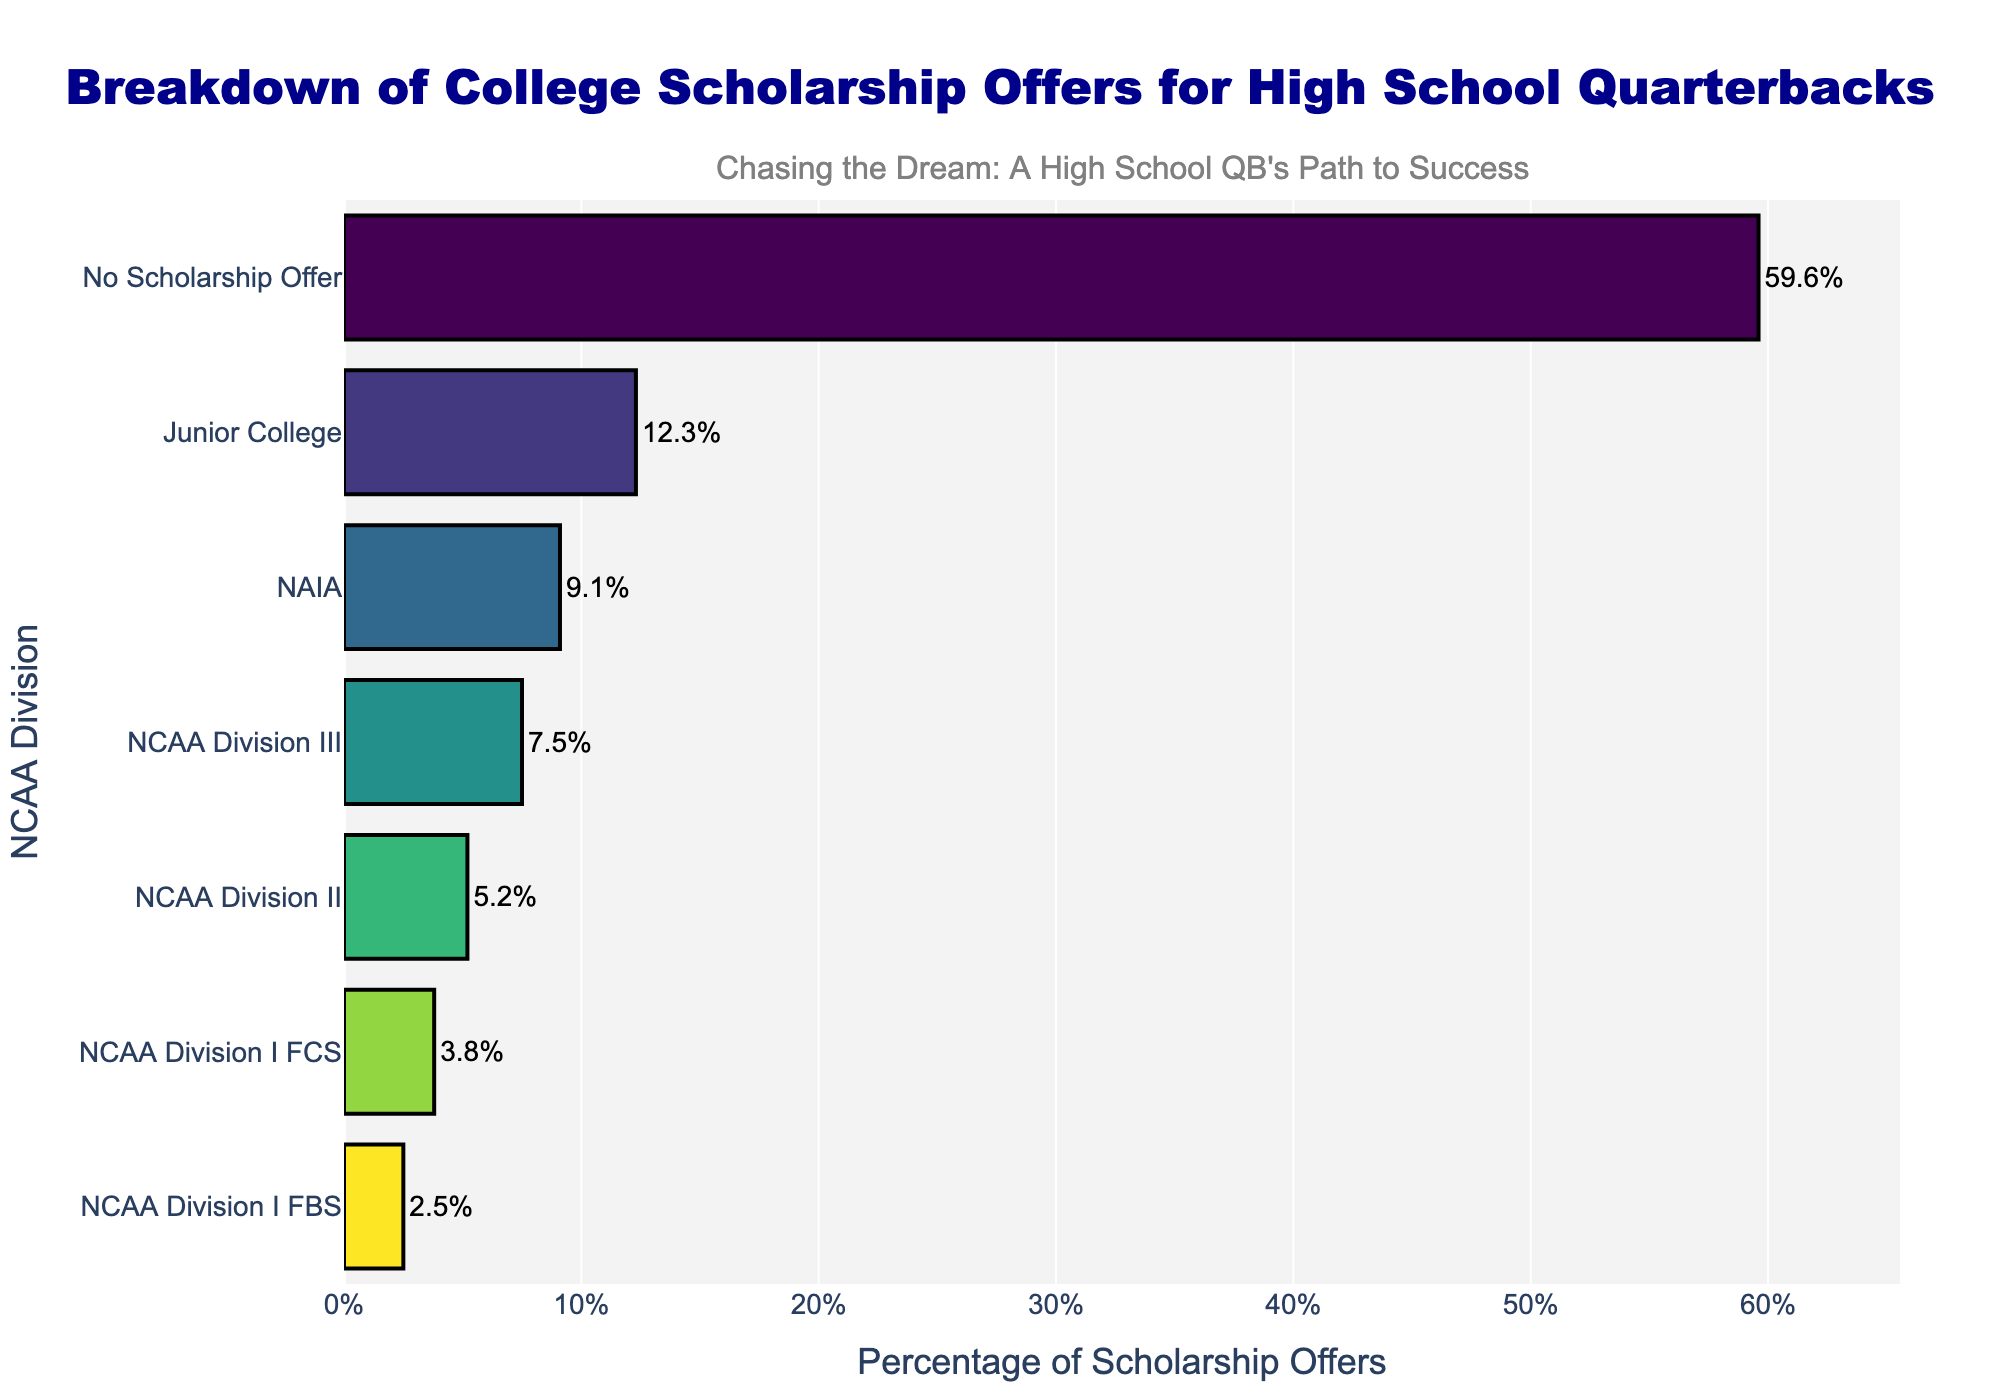Which division has the highest percentage of scholarship offers? By looking at the lengths of the bars, the "No Scholarship Offer" category has the longest bar, indicating the highest percentage.
Answer: No Scholarship Offer What is the difference in percentage between NCAA Division I FBS and NCAA Division II scholarship offers? Identify the percentages for both divisions, 2.5% for NCAA Division I FBS and 5.2% for NCAA Division II. Subtract 2.5% from 5.2% to find the difference.
Answer: 2.7% What is the combined percentage of scholarship offers for NCAA Division III and NAIA? Add the percentages of NCAA Division III (7.5%) and NAIA (9.1%) to get the combined percentage.
Answer: 16.6% Which division has the least percentage of scholarship offers? By looking at the lengths of the bars, NCAA Division I FBS has the shortest bar, indicating the lowest percentage.
Answer: NCAA Division I FBS What is the percentage difference between Junior College scholarship offers and NCAA Division I FCS? Identify the percentages for both divisions, 12.3% for Junior College and 3.8% for NCAA Division I FCS. Subtract 3.8% from 12.3% to find the difference.
Answer: 8.5% What is the average percentage of scholarship offers for NCAA Division I FCS, NCAA Division II, and NCAA Division III? Add the percentages for the three divisions and then divide by 3: (3.8% + 5.2% + 7.5%) / 3.
Answer: 5.5% Is the combined percentage of NCAA Division I FBS and NCAA Division I FCS greater than the percentage for NCAA Division III? Calculate the combined percentage (2.5% + 3.8%) which equals 6.3%, and compare it to 7.5% for NCAA Division III.
Answer: No How many divisions have a scholarship offer percentage greater than 5%? Identify the divisions with percentages higher than 5%: NCAA Division II, NCAA Division III, NAIA, and Junior College. Count these divisions.
Answer: 4 